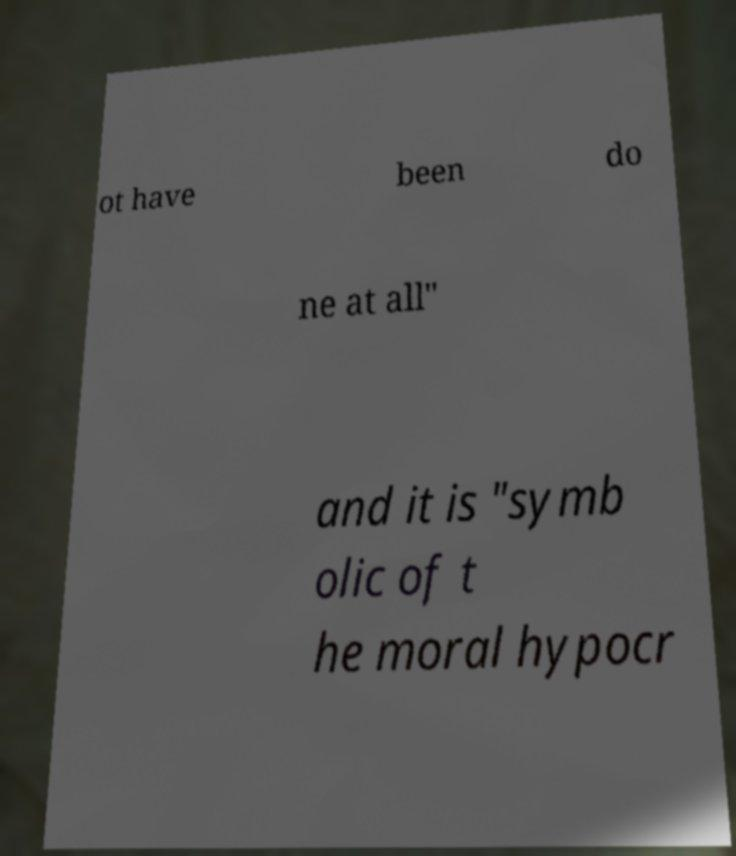I need the written content from this picture converted into text. Can you do that? ot have been do ne at all" and it is "symb olic of t he moral hypocr 